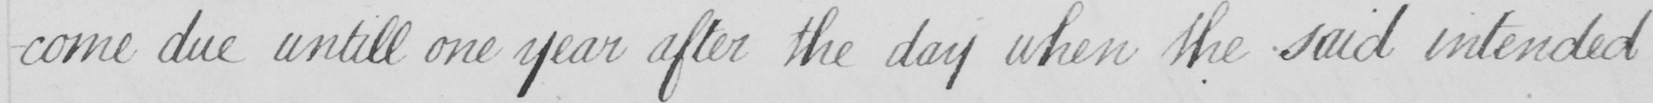What does this handwritten line say? -come due untill one year after the day when the said intended 